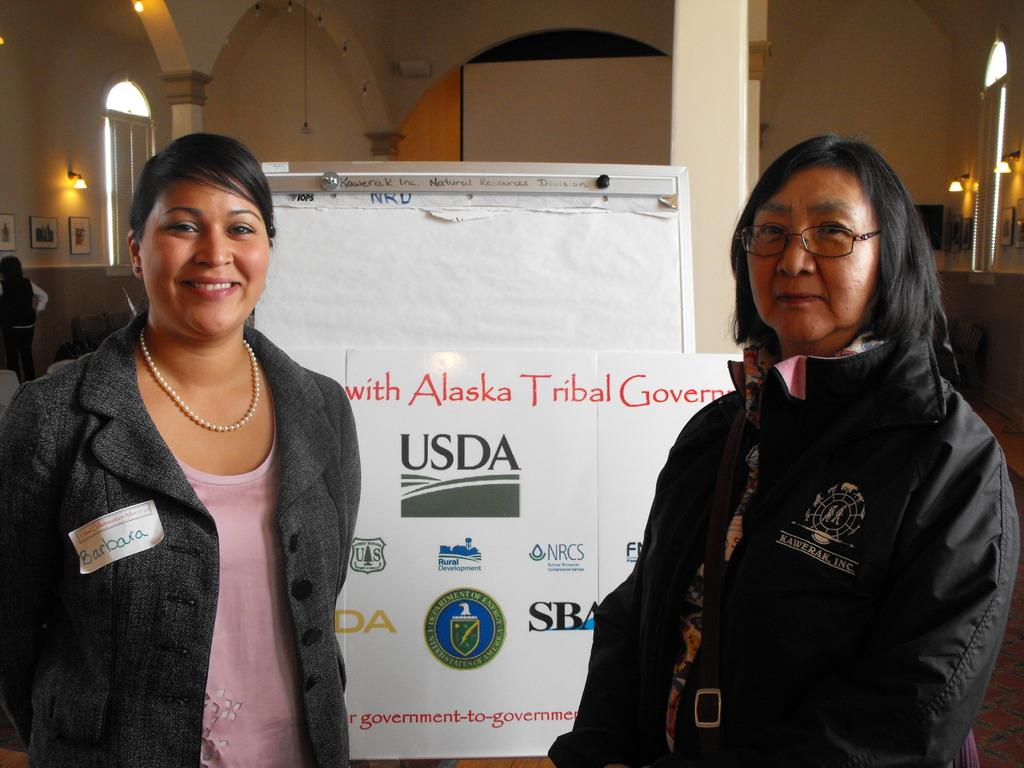How many people are present in the image? There are two persons in the image. What architectural features can be seen in the image? There are pillars in the image. What decorative items are attached to the walls in the image? There are photo frames attached to the walls in the image. What type of lighting is present in the image? There are lights in the image. What object can be used for displaying information or announcements? There is a board in the image. Can you see a playground in the image? There is no playground present in the image. What type of pin is holding the photo frames to the wall? The provided facts do not mention any pins holding the photo frames to the wall. Are there any mountains visible in the image? There are no mountains present in the image. 